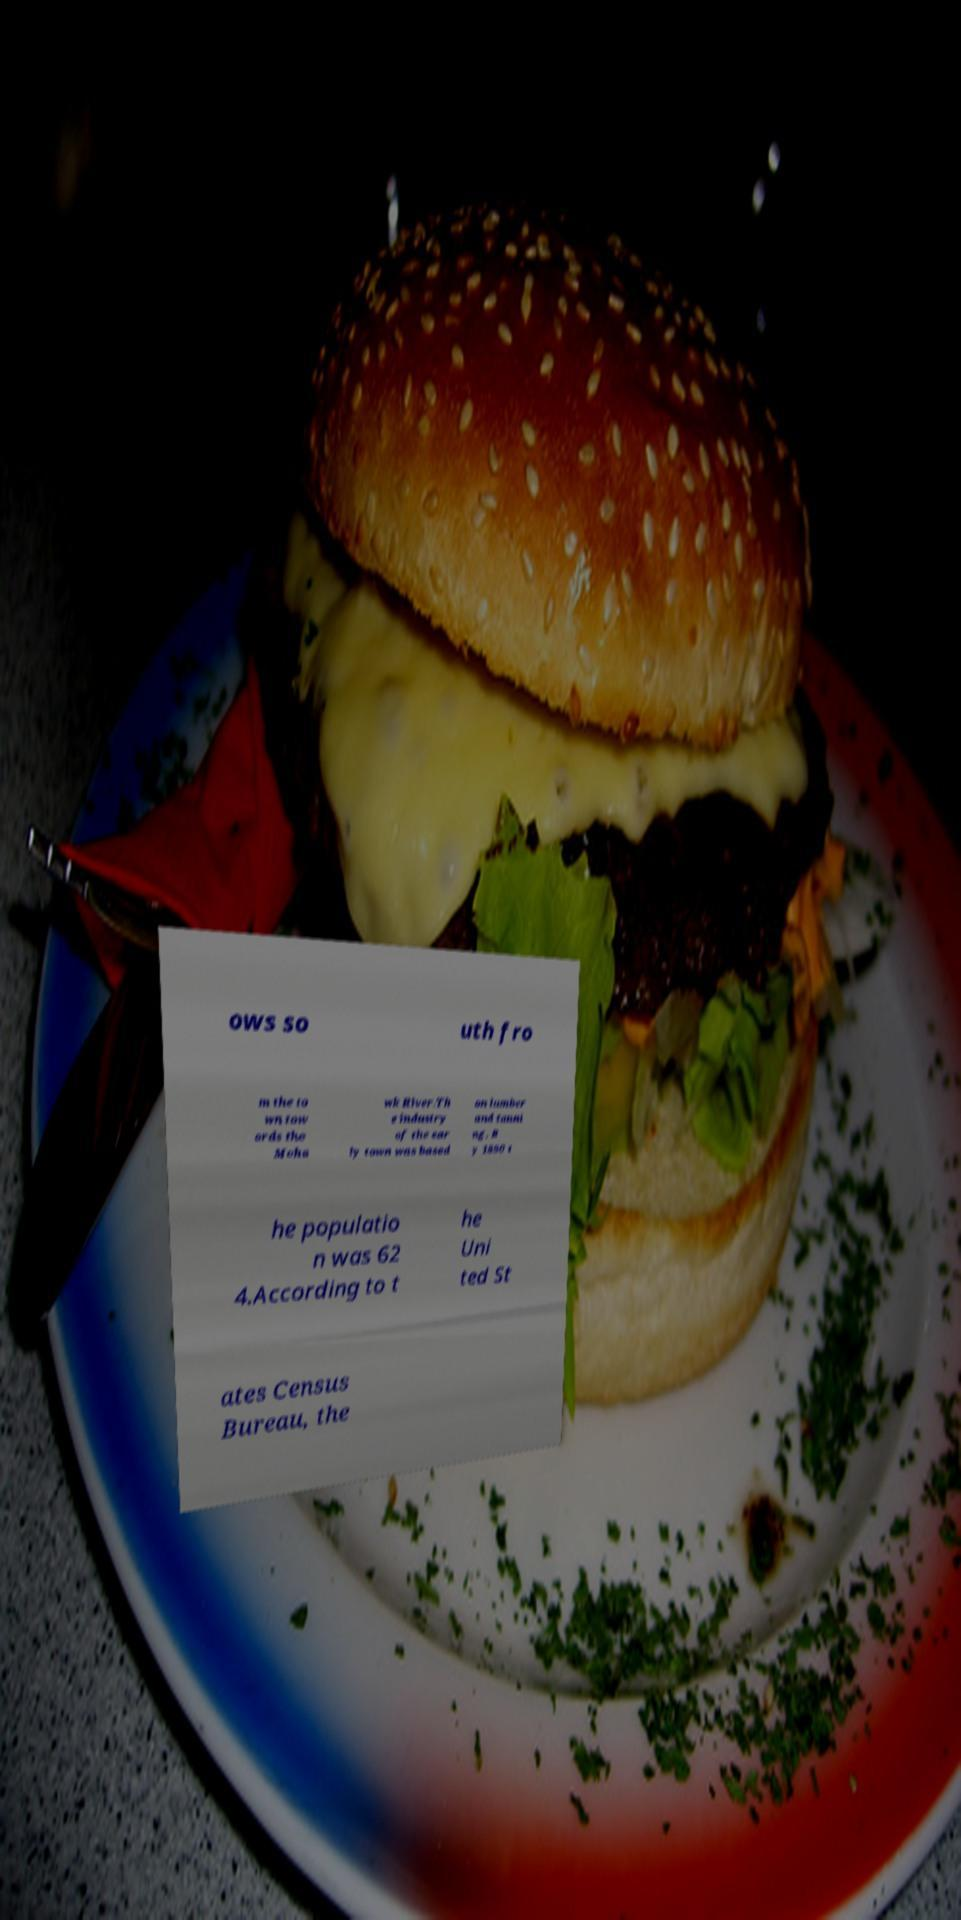Could you extract and type out the text from this image? ows so uth fro m the to wn tow ards the Moha wk River.Th e industry of the ear ly town was based on lumber and tanni ng. B y 1890 t he populatio n was 62 4.According to t he Uni ted St ates Census Bureau, the 